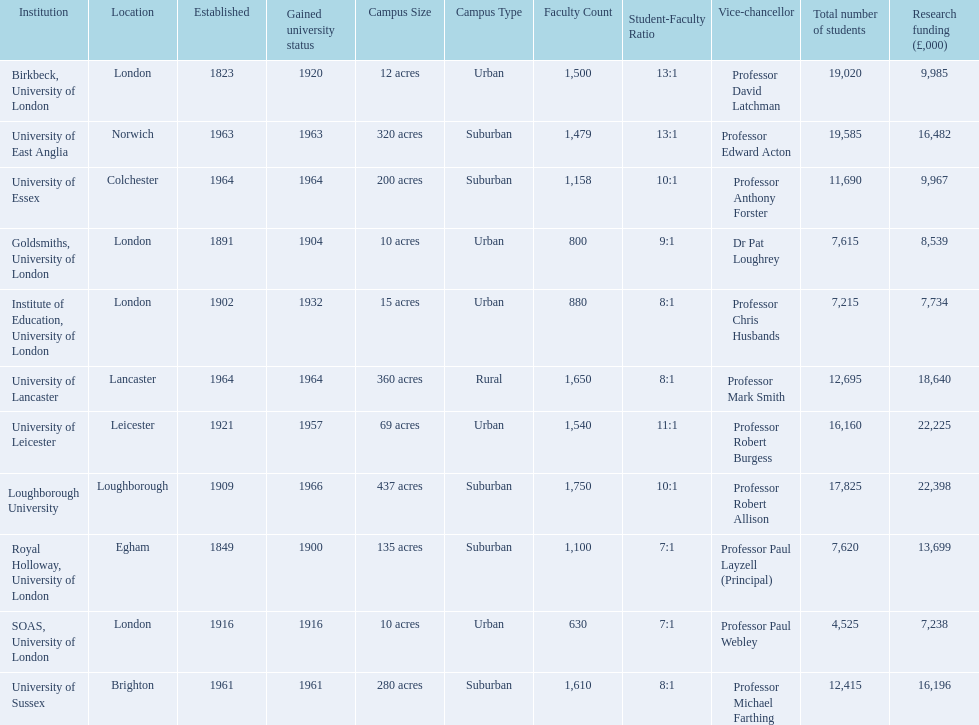How many of the institutions are located in london? 4. 